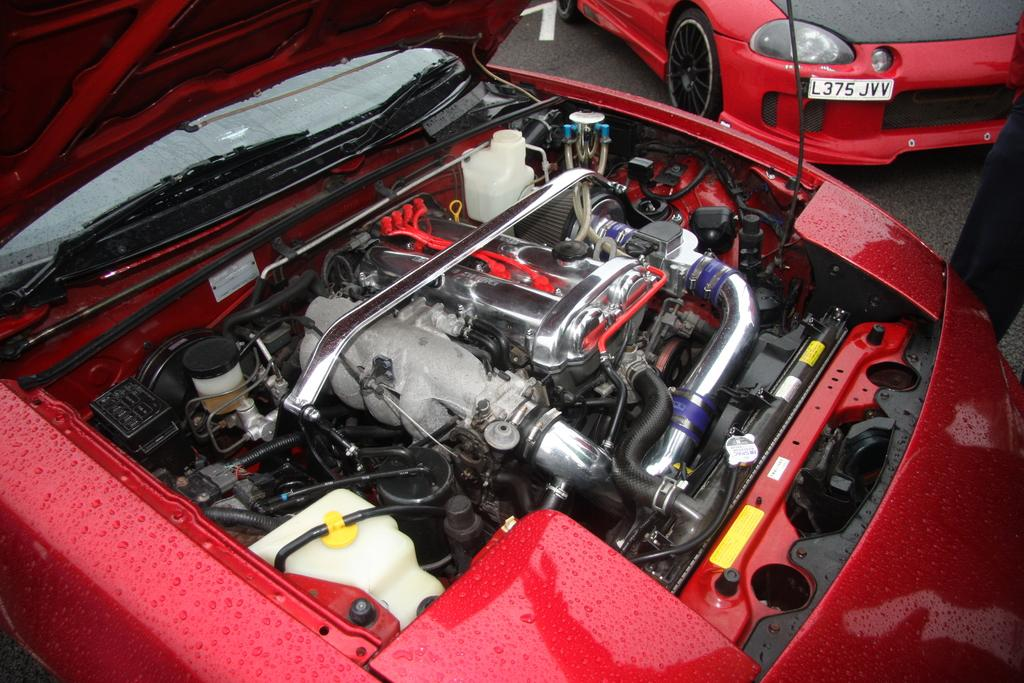What part of a car is visible in the image? The front part of a car is visible in the image. What can be seen attached to the car? There are cable wires on the car. What other objects are visible in the image besides the car? Pipes are visible in the image. Can you spot another car in the image? Yes, there is another car in the top right corner of the image. Is there any indication of a person in the image? A leg of a person may be visible in the image. What type of veil is draped over the car in the image? There is no veil present in the image; it only shows the front part of a car with cable wires and other objects. Is there a baseball game happening in the image? There is no indication of a baseball game or any sports activity in the image. 